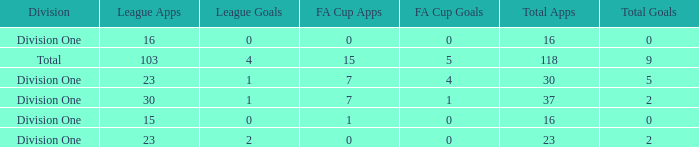It has a FA Cup Goals smaller than 4, and a FA Cup Apps larger than 7, what is the total number of total apps? 0.0. 